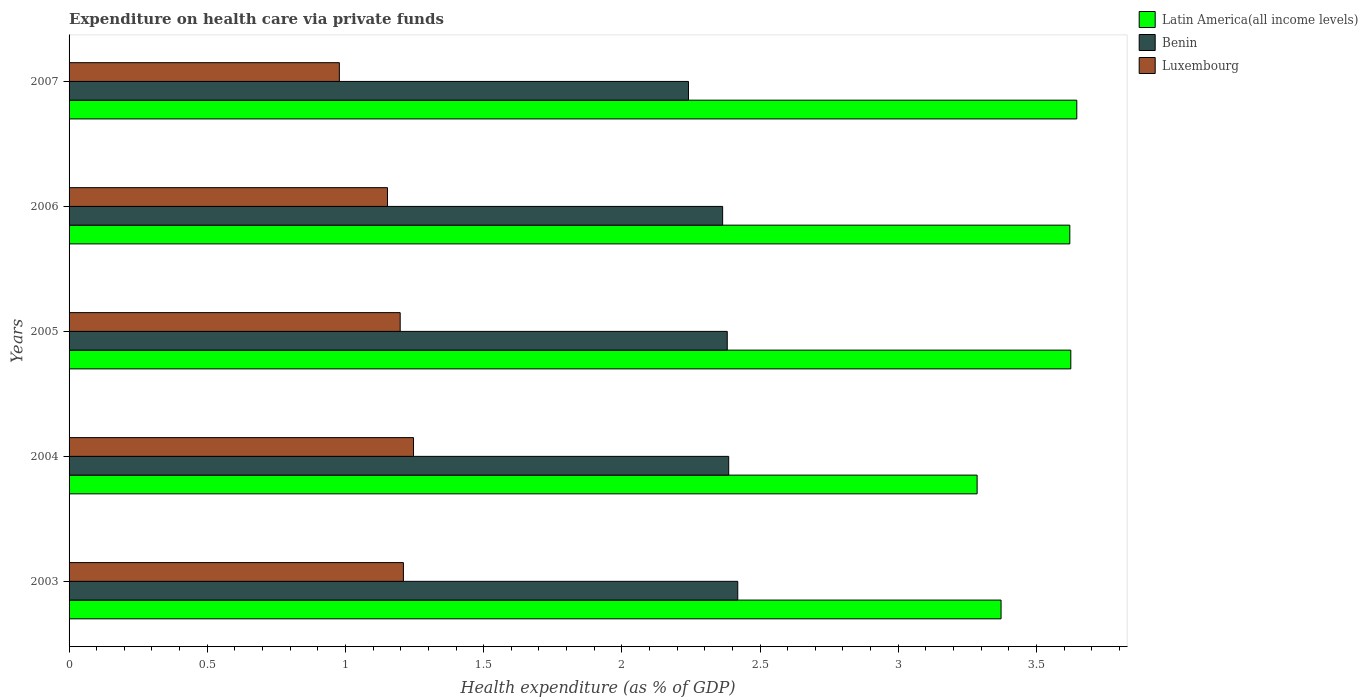How many groups of bars are there?
Make the answer very short. 5. Are the number of bars on each tick of the Y-axis equal?
Keep it short and to the point. Yes. How many bars are there on the 5th tick from the top?
Give a very brief answer. 3. How many bars are there on the 5th tick from the bottom?
Provide a succinct answer. 3. In how many cases, is the number of bars for a given year not equal to the number of legend labels?
Your response must be concise. 0. What is the expenditure made on health care in Latin America(all income levels) in 2004?
Your answer should be very brief. 3.29. Across all years, what is the maximum expenditure made on health care in Benin?
Your answer should be very brief. 2.42. Across all years, what is the minimum expenditure made on health care in Luxembourg?
Your answer should be very brief. 0.98. In which year was the expenditure made on health care in Luxembourg maximum?
Keep it short and to the point. 2004. What is the total expenditure made on health care in Luxembourg in the graph?
Your response must be concise. 5.78. What is the difference between the expenditure made on health care in Latin America(all income levels) in 2003 and that in 2005?
Keep it short and to the point. -0.25. What is the difference between the expenditure made on health care in Benin in 2005 and the expenditure made on health care in Luxembourg in 2007?
Offer a very short reply. 1.4. What is the average expenditure made on health care in Latin America(all income levels) per year?
Offer a terse response. 3.51. In the year 2004, what is the difference between the expenditure made on health care in Benin and expenditure made on health care in Luxembourg?
Provide a succinct answer. 1.14. In how many years, is the expenditure made on health care in Latin America(all income levels) greater than 1 %?
Offer a very short reply. 5. What is the ratio of the expenditure made on health care in Benin in 2005 to that in 2007?
Provide a short and direct response. 1.06. Is the expenditure made on health care in Latin America(all income levels) in 2005 less than that in 2006?
Provide a short and direct response. No. What is the difference between the highest and the second highest expenditure made on health care in Benin?
Your response must be concise. 0.03. What is the difference between the highest and the lowest expenditure made on health care in Luxembourg?
Offer a very short reply. 0.27. Is the sum of the expenditure made on health care in Benin in 2004 and 2007 greater than the maximum expenditure made on health care in Luxembourg across all years?
Your response must be concise. Yes. What does the 3rd bar from the top in 2004 represents?
Provide a short and direct response. Latin America(all income levels). What does the 2nd bar from the bottom in 2007 represents?
Your answer should be very brief. Benin. Is it the case that in every year, the sum of the expenditure made on health care in Luxembourg and expenditure made on health care in Benin is greater than the expenditure made on health care in Latin America(all income levels)?
Make the answer very short. No. How many bars are there?
Make the answer very short. 15. Are all the bars in the graph horizontal?
Ensure brevity in your answer.  Yes. How many years are there in the graph?
Ensure brevity in your answer.  5. Are the values on the major ticks of X-axis written in scientific E-notation?
Offer a very short reply. No. How many legend labels are there?
Keep it short and to the point. 3. What is the title of the graph?
Provide a short and direct response. Expenditure on health care via private funds. What is the label or title of the X-axis?
Keep it short and to the point. Health expenditure (as % of GDP). What is the Health expenditure (as % of GDP) of Latin America(all income levels) in 2003?
Offer a terse response. 3.37. What is the Health expenditure (as % of GDP) in Benin in 2003?
Give a very brief answer. 2.42. What is the Health expenditure (as % of GDP) in Luxembourg in 2003?
Keep it short and to the point. 1.21. What is the Health expenditure (as % of GDP) in Latin America(all income levels) in 2004?
Offer a very short reply. 3.29. What is the Health expenditure (as % of GDP) in Benin in 2004?
Your answer should be compact. 2.39. What is the Health expenditure (as % of GDP) of Luxembourg in 2004?
Offer a terse response. 1.25. What is the Health expenditure (as % of GDP) of Latin America(all income levels) in 2005?
Offer a very short reply. 3.62. What is the Health expenditure (as % of GDP) in Benin in 2005?
Offer a terse response. 2.38. What is the Health expenditure (as % of GDP) of Luxembourg in 2005?
Keep it short and to the point. 1.2. What is the Health expenditure (as % of GDP) in Latin America(all income levels) in 2006?
Offer a terse response. 3.62. What is the Health expenditure (as % of GDP) of Benin in 2006?
Keep it short and to the point. 2.36. What is the Health expenditure (as % of GDP) in Luxembourg in 2006?
Your answer should be very brief. 1.15. What is the Health expenditure (as % of GDP) of Latin America(all income levels) in 2007?
Your answer should be compact. 3.65. What is the Health expenditure (as % of GDP) of Benin in 2007?
Provide a succinct answer. 2.24. What is the Health expenditure (as % of GDP) of Luxembourg in 2007?
Keep it short and to the point. 0.98. Across all years, what is the maximum Health expenditure (as % of GDP) in Latin America(all income levels)?
Provide a succinct answer. 3.65. Across all years, what is the maximum Health expenditure (as % of GDP) in Benin?
Your answer should be very brief. 2.42. Across all years, what is the maximum Health expenditure (as % of GDP) in Luxembourg?
Provide a short and direct response. 1.25. Across all years, what is the minimum Health expenditure (as % of GDP) in Latin America(all income levels)?
Offer a very short reply. 3.29. Across all years, what is the minimum Health expenditure (as % of GDP) of Benin?
Make the answer very short. 2.24. Across all years, what is the minimum Health expenditure (as % of GDP) of Luxembourg?
Your answer should be very brief. 0.98. What is the total Health expenditure (as % of GDP) of Latin America(all income levels) in the graph?
Your answer should be compact. 17.55. What is the total Health expenditure (as % of GDP) in Benin in the graph?
Your answer should be very brief. 11.79. What is the total Health expenditure (as % of GDP) in Luxembourg in the graph?
Keep it short and to the point. 5.78. What is the difference between the Health expenditure (as % of GDP) of Latin America(all income levels) in 2003 and that in 2004?
Offer a terse response. 0.09. What is the difference between the Health expenditure (as % of GDP) in Benin in 2003 and that in 2004?
Your response must be concise. 0.03. What is the difference between the Health expenditure (as % of GDP) in Luxembourg in 2003 and that in 2004?
Ensure brevity in your answer.  -0.04. What is the difference between the Health expenditure (as % of GDP) of Latin America(all income levels) in 2003 and that in 2005?
Your answer should be very brief. -0.25. What is the difference between the Health expenditure (as % of GDP) of Benin in 2003 and that in 2005?
Keep it short and to the point. 0.04. What is the difference between the Health expenditure (as % of GDP) in Luxembourg in 2003 and that in 2005?
Offer a very short reply. 0.01. What is the difference between the Health expenditure (as % of GDP) in Latin America(all income levels) in 2003 and that in 2006?
Your answer should be very brief. -0.25. What is the difference between the Health expenditure (as % of GDP) in Benin in 2003 and that in 2006?
Your response must be concise. 0.05. What is the difference between the Health expenditure (as % of GDP) of Luxembourg in 2003 and that in 2006?
Ensure brevity in your answer.  0.06. What is the difference between the Health expenditure (as % of GDP) of Latin America(all income levels) in 2003 and that in 2007?
Offer a very short reply. -0.27. What is the difference between the Health expenditure (as % of GDP) in Benin in 2003 and that in 2007?
Give a very brief answer. 0.18. What is the difference between the Health expenditure (as % of GDP) of Luxembourg in 2003 and that in 2007?
Your response must be concise. 0.23. What is the difference between the Health expenditure (as % of GDP) of Latin America(all income levels) in 2004 and that in 2005?
Offer a terse response. -0.34. What is the difference between the Health expenditure (as % of GDP) in Benin in 2004 and that in 2005?
Offer a terse response. 0.01. What is the difference between the Health expenditure (as % of GDP) of Luxembourg in 2004 and that in 2005?
Make the answer very short. 0.05. What is the difference between the Health expenditure (as % of GDP) of Latin America(all income levels) in 2004 and that in 2006?
Offer a terse response. -0.34. What is the difference between the Health expenditure (as % of GDP) of Benin in 2004 and that in 2006?
Provide a short and direct response. 0.02. What is the difference between the Health expenditure (as % of GDP) of Luxembourg in 2004 and that in 2006?
Make the answer very short. 0.09. What is the difference between the Health expenditure (as % of GDP) of Latin America(all income levels) in 2004 and that in 2007?
Offer a very short reply. -0.36. What is the difference between the Health expenditure (as % of GDP) of Benin in 2004 and that in 2007?
Offer a terse response. 0.15. What is the difference between the Health expenditure (as % of GDP) in Luxembourg in 2004 and that in 2007?
Provide a succinct answer. 0.27. What is the difference between the Health expenditure (as % of GDP) of Latin America(all income levels) in 2005 and that in 2006?
Make the answer very short. 0. What is the difference between the Health expenditure (as % of GDP) of Benin in 2005 and that in 2006?
Offer a very short reply. 0.02. What is the difference between the Health expenditure (as % of GDP) of Luxembourg in 2005 and that in 2006?
Ensure brevity in your answer.  0.05. What is the difference between the Health expenditure (as % of GDP) in Latin America(all income levels) in 2005 and that in 2007?
Ensure brevity in your answer.  -0.02. What is the difference between the Health expenditure (as % of GDP) in Benin in 2005 and that in 2007?
Your response must be concise. 0.14. What is the difference between the Health expenditure (as % of GDP) of Luxembourg in 2005 and that in 2007?
Your answer should be compact. 0.22. What is the difference between the Health expenditure (as % of GDP) of Latin America(all income levels) in 2006 and that in 2007?
Keep it short and to the point. -0.03. What is the difference between the Health expenditure (as % of GDP) in Benin in 2006 and that in 2007?
Ensure brevity in your answer.  0.12. What is the difference between the Health expenditure (as % of GDP) in Luxembourg in 2006 and that in 2007?
Provide a short and direct response. 0.17. What is the difference between the Health expenditure (as % of GDP) of Latin America(all income levels) in 2003 and the Health expenditure (as % of GDP) of Benin in 2004?
Offer a terse response. 0.99. What is the difference between the Health expenditure (as % of GDP) of Latin America(all income levels) in 2003 and the Health expenditure (as % of GDP) of Luxembourg in 2004?
Ensure brevity in your answer.  2.13. What is the difference between the Health expenditure (as % of GDP) in Benin in 2003 and the Health expenditure (as % of GDP) in Luxembourg in 2004?
Offer a very short reply. 1.17. What is the difference between the Health expenditure (as % of GDP) in Latin America(all income levels) in 2003 and the Health expenditure (as % of GDP) in Luxembourg in 2005?
Your answer should be compact. 2.17. What is the difference between the Health expenditure (as % of GDP) in Benin in 2003 and the Health expenditure (as % of GDP) in Luxembourg in 2005?
Make the answer very short. 1.22. What is the difference between the Health expenditure (as % of GDP) in Latin America(all income levels) in 2003 and the Health expenditure (as % of GDP) in Benin in 2006?
Make the answer very short. 1.01. What is the difference between the Health expenditure (as % of GDP) of Latin America(all income levels) in 2003 and the Health expenditure (as % of GDP) of Luxembourg in 2006?
Your answer should be compact. 2.22. What is the difference between the Health expenditure (as % of GDP) in Benin in 2003 and the Health expenditure (as % of GDP) in Luxembourg in 2006?
Ensure brevity in your answer.  1.27. What is the difference between the Health expenditure (as % of GDP) in Latin America(all income levels) in 2003 and the Health expenditure (as % of GDP) in Benin in 2007?
Keep it short and to the point. 1.13. What is the difference between the Health expenditure (as % of GDP) of Latin America(all income levels) in 2003 and the Health expenditure (as % of GDP) of Luxembourg in 2007?
Offer a very short reply. 2.39. What is the difference between the Health expenditure (as % of GDP) in Benin in 2003 and the Health expenditure (as % of GDP) in Luxembourg in 2007?
Give a very brief answer. 1.44. What is the difference between the Health expenditure (as % of GDP) in Latin America(all income levels) in 2004 and the Health expenditure (as % of GDP) in Benin in 2005?
Keep it short and to the point. 0.9. What is the difference between the Health expenditure (as % of GDP) in Latin America(all income levels) in 2004 and the Health expenditure (as % of GDP) in Luxembourg in 2005?
Your response must be concise. 2.09. What is the difference between the Health expenditure (as % of GDP) in Benin in 2004 and the Health expenditure (as % of GDP) in Luxembourg in 2005?
Give a very brief answer. 1.19. What is the difference between the Health expenditure (as % of GDP) of Latin America(all income levels) in 2004 and the Health expenditure (as % of GDP) of Benin in 2006?
Keep it short and to the point. 0.92. What is the difference between the Health expenditure (as % of GDP) in Latin America(all income levels) in 2004 and the Health expenditure (as % of GDP) in Luxembourg in 2006?
Your answer should be very brief. 2.13. What is the difference between the Health expenditure (as % of GDP) of Benin in 2004 and the Health expenditure (as % of GDP) of Luxembourg in 2006?
Offer a very short reply. 1.23. What is the difference between the Health expenditure (as % of GDP) in Latin America(all income levels) in 2004 and the Health expenditure (as % of GDP) in Benin in 2007?
Make the answer very short. 1.04. What is the difference between the Health expenditure (as % of GDP) in Latin America(all income levels) in 2004 and the Health expenditure (as % of GDP) in Luxembourg in 2007?
Give a very brief answer. 2.31. What is the difference between the Health expenditure (as % of GDP) in Benin in 2004 and the Health expenditure (as % of GDP) in Luxembourg in 2007?
Provide a short and direct response. 1.41. What is the difference between the Health expenditure (as % of GDP) in Latin America(all income levels) in 2005 and the Health expenditure (as % of GDP) in Benin in 2006?
Offer a terse response. 1.26. What is the difference between the Health expenditure (as % of GDP) in Latin America(all income levels) in 2005 and the Health expenditure (as % of GDP) in Luxembourg in 2006?
Provide a short and direct response. 2.47. What is the difference between the Health expenditure (as % of GDP) in Benin in 2005 and the Health expenditure (as % of GDP) in Luxembourg in 2006?
Give a very brief answer. 1.23. What is the difference between the Health expenditure (as % of GDP) in Latin America(all income levels) in 2005 and the Health expenditure (as % of GDP) in Benin in 2007?
Your response must be concise. 1.38. What is the difference between the Health expenditure (as % of GDP) in Latin America(all income levels) in 2005 and the Health expenditure (as % of GDP) in Luxembourg in 2007?
Your answer should be compact. 2.65. What is the difference between the Health expenditure (as % of GDP) of Benin in 2005 and the Health expenditure (as % of GDP) of Luxembourg in 2007?
Make the answer very short. 1.4. What is the difference between the Health expenditure (as % of GDP) of Latin America(all income levels) in 2006 and the Health expenditure (as % of GDP) of Benin in 2007?
Offer a terse response. 1.38. What is the difference between the Health expenditure (as % of GDP) of Latin America(all income levels) in 2006 and the Health expenditure (as % of GDP) of Luxembourg in 2007?
Offer a terse response. 2.64. What is the difference between the Health expenditure (as % of GDP) in Benin in 2006 and the Health expenditure (as % of GDP) in Luxembourg in 2007?
Your answer should be very brief. 1.39. What is the average Health expenditure (as % of GDP) in Latin America(all income levels) per year?
Your answer should be very brief. 3.51. What is the average Health expenditure (as % of GDP) in Benin per year?
Make the answer very short. 2.36. What is the average Health expenditure (as % of GDP) of Luxembourg per year?
Provide a succinct answer. 1.16. In the year 2003, what is the difference between the Health expenditure (as % of GDP) of Latin America(all income levels) and Health expenditure (as % of GDP) of Benin?
Provide a short and direct response. 0.95. In the year 2003, what is the difference between the Health expenditure (as % of GDP) of Latin America(all income levels) and Health expenditure (as % of GDP) of Luxembourg?
Keep it short and to the point. 2.16. In the year 2003, what is the difference between the Health expenditure (as % of GDP) in Benin and Health expenditure (as % of GDP) in Luxembourg?
Ensure brevity in your answer.  1.21. In the year 2004, what is the difference between the Health expenditure (as % of GDP) in Latin America(all income levels) and Health expenditure (as % of GDP) in Benin?
Provide a succinct answer. 0.9. In the year 2004, what is the difference between the Health expenditure (as % of GDP) of Latin America(all income levels) and Health expenditure (as % of GDP) of Luxembourg?
Ensure brevity in your answer.  2.04. In the year 2004, what is the difference between the Health expenditure (as % of GDP) of Benin and Health expenditure (as % of GDP) of Luxembourg?
Give a very brief answer. 1.14. In the year 2005, what is the difference between the Health expenditure (as % of GDP) in Latin America(all income levels) and Health expenditure (as % of GDP) in Benin?
Ensure brevity in your answer.  1.24. In the year 2005, what is the difference between the Health expenditure (as % of GDP) of Latin America(all income levels) and Health expenditure (as % of GDP) of Luxembourg?
Give a very brief answer. 2.43. In the year 2005, what is the difference between the Health expenditure (as % of GDP) of Benin and Health expenditure (as % of GDP) of Luxembourg?
Offer a very short reply. 1.18. In the year 2006, what is the difference between the Health expenditure (as % of GDP) in Latin America(all income levels) and Health expenditure (as % of GDP) in Benin?
Give a very brief answer. 1.26. In the year 2006, what is the difference between the Health expenditure (as % of GDP) in Latin America(all income levels) and Health expenditure (as % of GDP) in Luxembourg?
Your response must be concise. 2.47. In the year 2006, what is the difference between the Health expenditure (as % of GDP) in Benin and Health expenditure (as % of GDP) in Luxembourg?
Ensure brevity in your answer.  1.21. In the year 2007, what is the difference between the Health expenditure (as % of GDP) of Latin America(all income levels) and Health expenditure (as % of GDP) of Benin?
Keep it short and to the point. 1.41. In the year 2007, what is the difference between the Health expenditure (as % of GDP) of Latin America(all income levels) and Health expenditure (as % of GDP) of Luxembourg?
Make the answer very short. 2.67. In the year 2007, what is the difference between the Health expenditure (as % of GDP) of Benin and Health expenditure (as % of GDP) of Luxembourg?
Offer a terse response. 1.26. What is the ratio of the Health expenditure (as % of GDP) of Latin America(all income levels) in 2003 to that in 2004?
Your response must be concise. 1.03. What is the ratio of the Health expenditure (as % of GDP) of Benin in 2003 to that in 2004?
Ensure brevity in your answer.  1.01. What is the ratio of the Health expenditure (as % of GDP) of Luxembourg in 2003 to that in 2004?
Your answer should be compact. 0.97. What is the ratio of the Health expenditure (as % of GDP) of Latin America(all income levels) in 2003 to that in 2005?
Your answer should be very brief. 0.93. What is the ratio of the Health expenditure (as % of GDP) in Luxembourg in 2003 to that in 2005?
Ensure brevity in your answer.  1.01. What is the ratio of the Health expenditure (as % of GDP) in Latin America(all income levels) in 2003 to that in 2006?
Provide a short and direct response. 0.93. What is the ratio of the Health expenditure (as % of GDP) in Benin in 2003 to that in 2006?
Provide a short and direct response. 1.02. What is the ratio of the Health expenditure (as % of GDP) of Latin America(all income levels) in 2003 to that in 2007?
Give a very brief answer. 0.92. What is the ratio of the Health expenditure (as % of GDP) in Benin in 2003 to that in 2007?
Provide a short and direct response. 1.08. What is the ratio of the Health expenditure (as % of GDP) in Luxembourg in 2003 to that in 2007?
Offer a terse response. 1.24. What is the ratio of the Health expenditure (as % of GDP) of Latin America(all income levels) in 2004 to that in 2005?
Provide a succinct answer. 0.91. What is the ratio of the Health expenditure (as % of GDP) of Benin in 2004 to that in 2005?
Offer a terse response. 1. What is the ratio of the Health expenditure (as % of GDP) of Luxembourg in 2004 to that in 2005?
Make the answer very short. 1.04. What is the ratio of the Health expenditure (as % of GDP) in Latin America(all income levels) in 2004 to that in 2006?
Offer a very short reply. 0.91. What is the ratio of the Health expenditure (as % of GDP) of Benin in 2004 to that in 2006?
Keep it short and to the point. 1.01. What is the ratio of the Health expenditure (as % of GDP) in Luxembourg in 2004 to that in 2006?
Your response must be concise. 1.08. What is the ratio of the Health expenditure (as % of GDP) of Latin America(all income levels) in 2004 to that in 2007?
Make the answer very short. 0.9. What is the ratio of the Health expenditure (as % of GDP) of Benin in 2004 to that in 2007?
Offer a terse response. 1.06. What is the ratio of the Health expenditure (as % of GDP) of Luxembourg in 2004 to that in 2007?
Ensure brevity in your answer.  1.27. What is the ratio of the Health expenditure (as % of GDP) in Latin America(all income levels) in 2005 to that in 2006?
Your answer should be very brief. 1. What is the ratio of the Health expenditure (as % of GDP) in Benin in 2005 to that in 2006?
Give a very brief answer. 1.01. What is the ratio of the Health expenditure (as % of GDP) of Luxembourg in 2005 to that in 2006?
Your response must be concise. 1.04. What is the ratio of the Health expenditure (as % of GDP) of Benin in 2005 to that in 2007?
Give a very brief answer. 1.06. What is the ratio of the Health expenditure (as % of GDP) of Luxembourg in 2005 to that in 2007?
Offer a terse response. 1.23. What is the ratio of the Health expenditure (as % of GDP) of Benin in 2006 to that in 2007?
Provide a short and direct response. 1.06. What is the ratio of the Health expenditure (as % of GDP) in Luxembourg in 2006 to that in 2007?
Offer a very short reply. 1.18. What is the difference between the highest and the second highest Health expenditure (as % of GDP) in Latin America(all income levels)?
Give a very brief answer. 0.02. What is the difference between the highest and the second highest Health expenditure (as % of GDP) of Benin?
Offer a terse response. 0.03. What is the difference between the highest and the second highest Health expenditure (as % of GDP) in Luxembourg?
Offer a very short reply. 0.04. What is the difference between the highest and the lowest Health expenditure (as % of GDP) of Latin America(all income levels)?
Offer a very short reply. 0.36. What is the difference between the highest and the lowest Health expenditure (as % of GDP) of Benin?
Keep it short and to the point. 0.18. What is the difference between the highest and the lowest Health expenditure (as % of GDP) in Luxembourg?
Give a very brief answer. 0.27. 